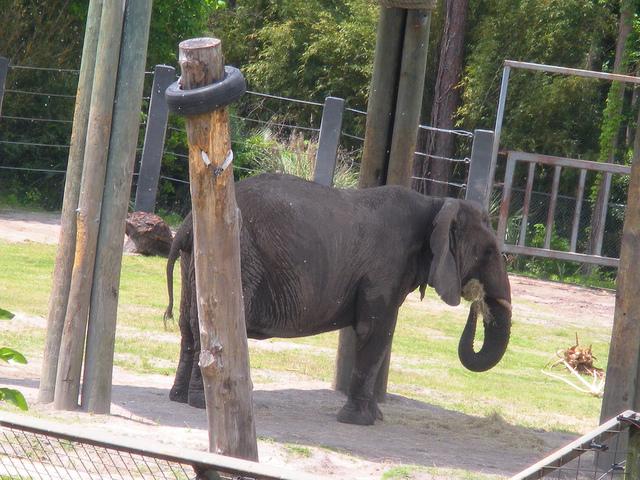Is the elephant in the wild?
Answer briefly. No. Is there a tire?
Answer briefly. Yes. How many logs are there?
Write a very short answer. 1. Is the elephant eating?
Concise answer only. Yes. 